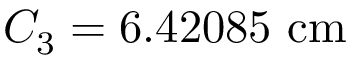Convert formula to latex. <formula><loc_0><loc_0><loc_500><loc_500>C _ { 3 } = 6 . 4 2 0 8 5 \ c m</formula> 